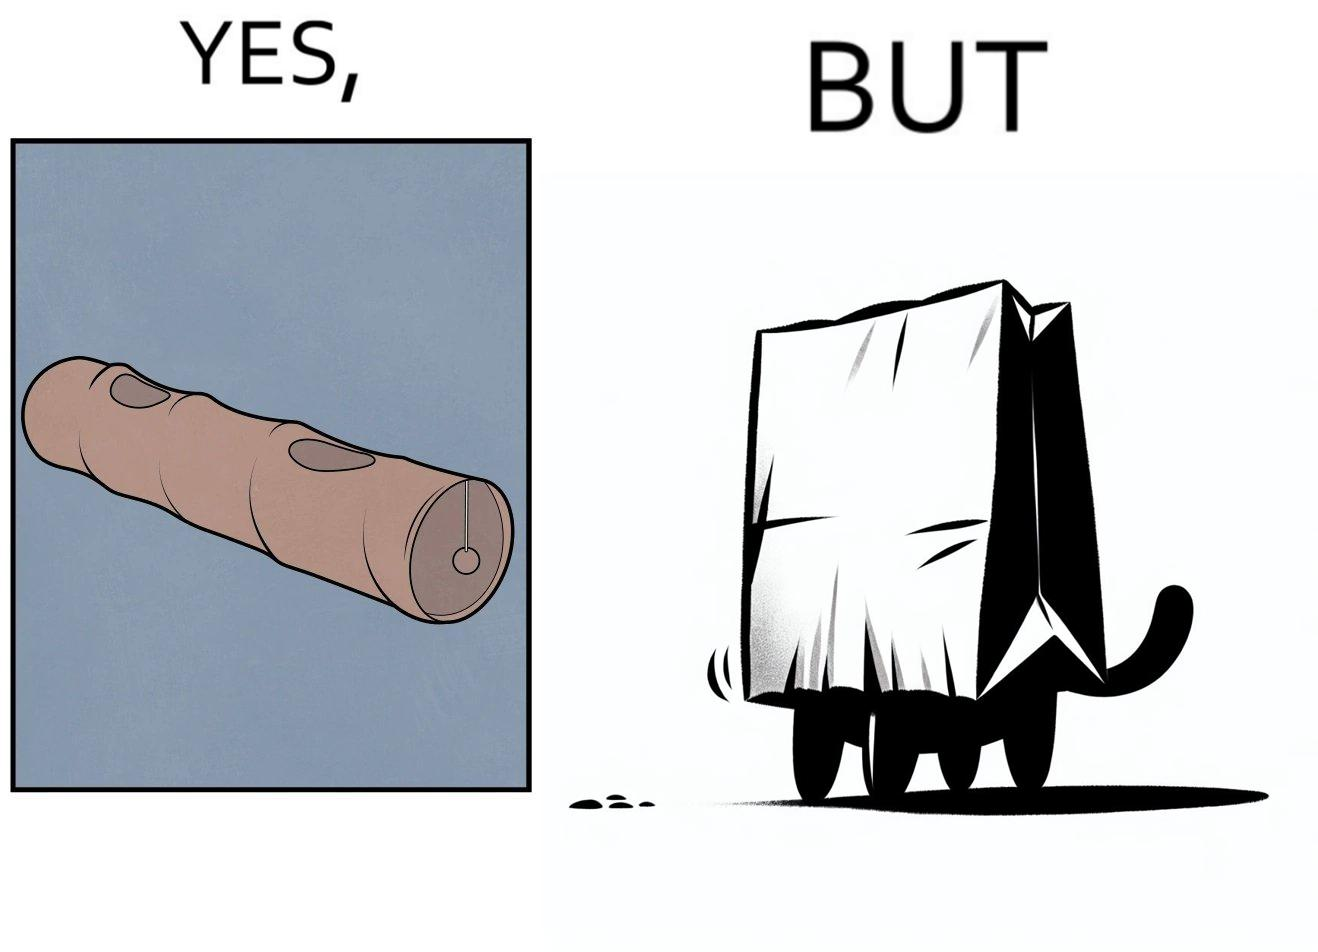Describe what you see in this image. The image is funny, because even when there is a dedicated thing for the animal to play with it still is hiding itself in the paper bag 